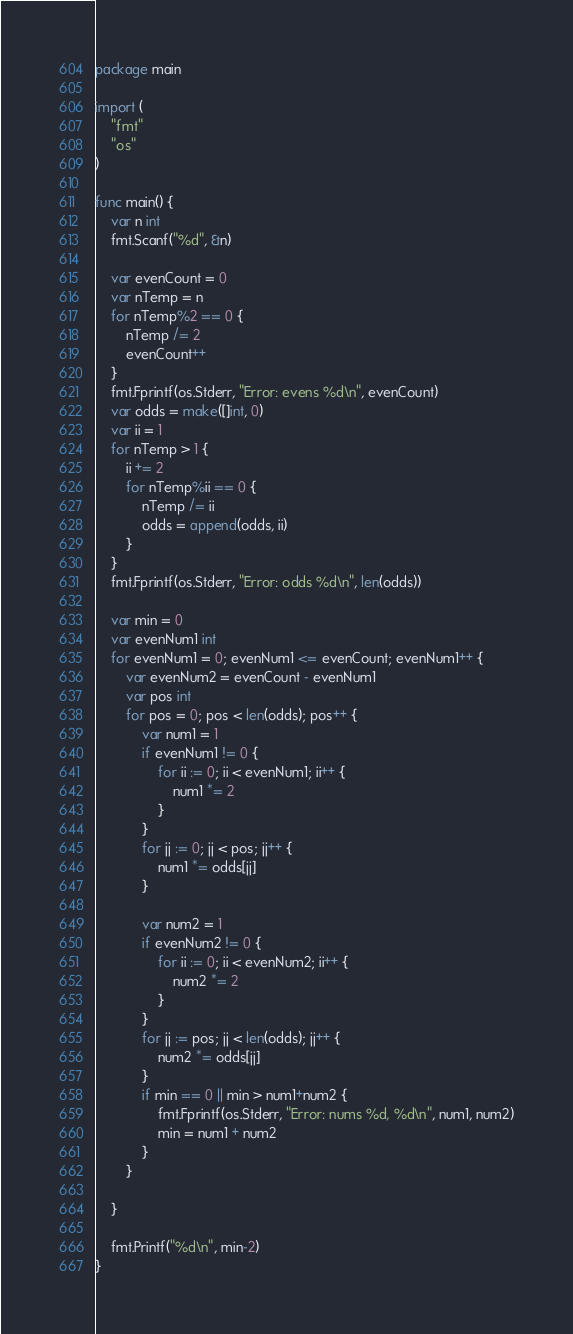<code> <loc_0><loc_0><loc_500><loc_500><_Go_>package main

import (
	"fmt"
	"os"
)

func main() {
	var n int
	fmt.Scanf("%d", &n)

	var evenCount = 0
	var nTemp = n
	for nTemp%2 == 0 {
		nTemp /= 2
		evenCount++
	}
	fmt.Fprintf(os.Stderr, "Error: evens %d\n", evenCount)
	var odds = make([]int, 0)
	var ii = 1
	for nTemp > 1 {
		ii += 2
		for nTemp%ii == 0 {
			nTemp /= ii
			odds = append(odds, ii)
		}
	}
	fmt.Fprintf(os.Stderr, "Error: odds %d\n", len(odds))

	var min = 0
	var evenNum1 int
	for evenNum1 = 0; evenNum1 <= evenCount; evenNum1++ {
		var evenNum2 = evenCount - evenNum1
		var pos int
		for pos = 0; pos < len(odds); pos++ {
			var num1 = 1
			if evenNum1 != 0 {
				for ii := 0; ii < evenNum1; ii++ {
					num1 *= 2
				}
			}
			for jj := 0; jj < pos; jj++ {
				num1 *= odds[jj]
			}

			var num2 = 1
			if evenNum2 != 0 {
				for ii := 0; ii < evenNum2; ii++ {
					num2 *= 2
				}
			}
			for jj := pos; jj < len(odds); jj++ {
				num2 *= odds[jj]
			}
			if min == 0 || min > num1+num2 {
				fmt.Fprintf(os.Stderr, "Error: nums %d, %d\n", num1, num2)
				min = num1 + num2
			}
		}

	}

	fmt.Printf("%d\n", min-2)
}
</code> 